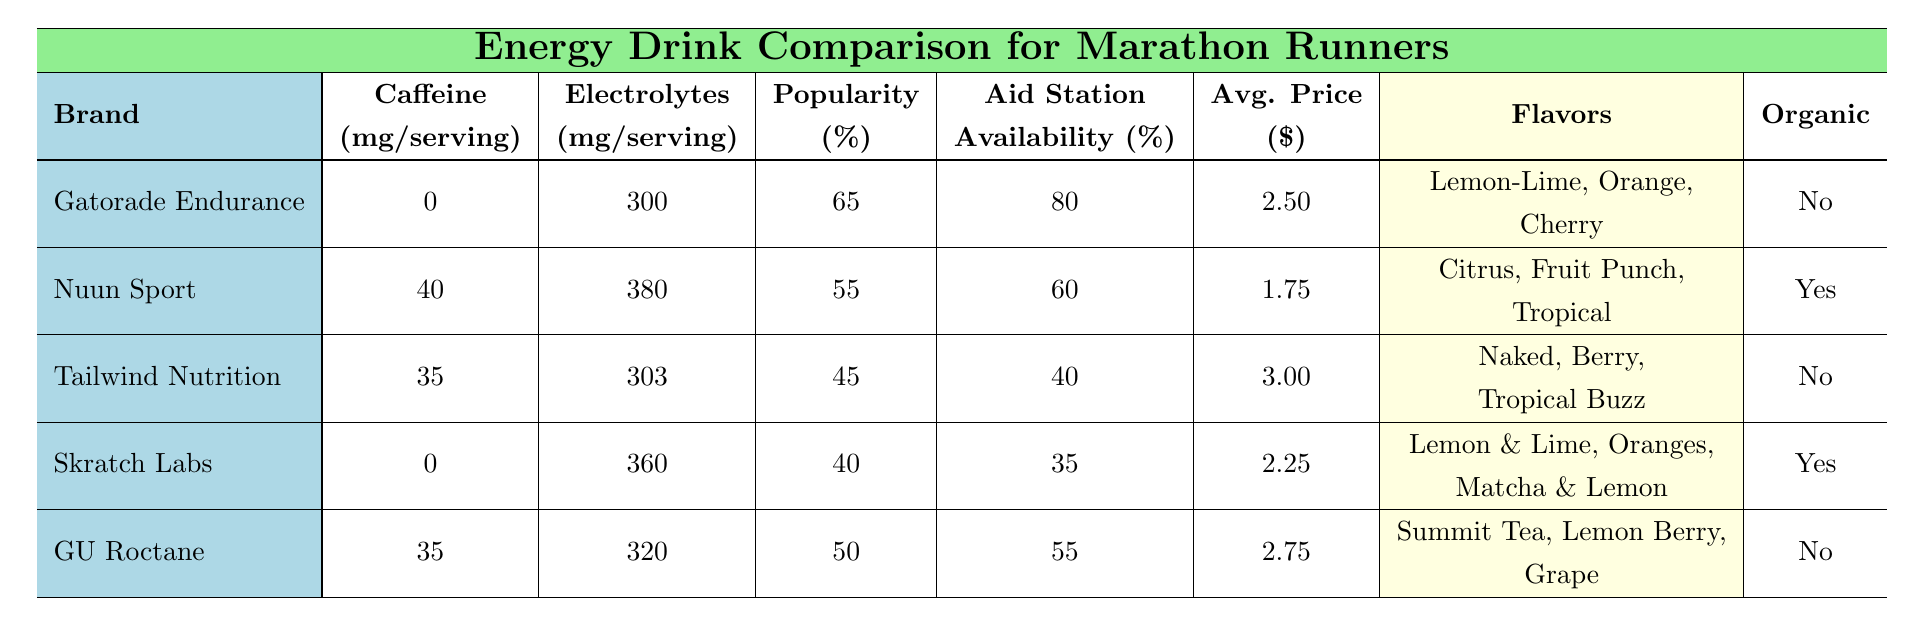What is the average caffeine content in the energy drinks listed? The caffeine contents listed are: 0, 40, 35, 0, and 35 mg. Adding these values gives 0 + 40 + 35 + 0 + 35 = 110 mg. There are 5 drinks, so the average is 110 / 5 = 22 mg.
Answer: 22 mg Which energy drink has the highest popularity among runners? The popularity percentages are: Gatorade Endurance: 65%, Nuun Sport: 55%, Tailwind Nutrition: 45%, Skratch Labs: 40%, and GU Roctane: 50%. Gatorade Endurance has the highest percentage at 65%.
Answer: Gatorade Endurance Is Nuun Sport organic? The table indicates that Nuun Sport is marked as "Yes" in the Organic column.
Answer: Yes What is the combined electrolytes content for Skratch Labs and Tailwind Nutrition? Skratch Labs has an electrolyte content of 360 mg, and Tailwind Nutrition has 303 mg. Adding these gives 360 + 303 = 663 mg for both drinks combined.
Answer: 663 mg Which drink is most frequently available at aid stations and what is that percentage? The availability percentages are Gatorade Endurance: 80%, Nuun Sport: 60%, Tailwind Nutrition: 40%, Skratch Labs: 35%, and GU Roctane: 55%. Gatorade Endurance is available at the highest percentage of 80%.
Answer: Gatorade Endurance, 80% What is the price range of the energy drinks listed? The average prices are: Gatorade Endurance: $2.50, Nuun Sport: $1.75, Tailwind Nutrition: $3.00, Skratch Labs: $2.25, GU Roctane: $2.75. The lowest price is $1.75, and the highest is $3.00.
Answer: $1.75 - $3.00 If we consider only drinks with caffeine, what is the percentage popularity of those drinks? The drinks with caffeine are Nuun Sport (55% popularity), Tailwind Nutrition (45%), and GU Roctane (50%). So, 3 drinks out of 5 have caffeine. The combined popularity is 55 + 45 + 50 = 150%. To find the percentage popularity of those drinks relative to all drinks: (150 / (65 + 55 + 45 + 40 + 50)) * 100 = (150 / 255) * 100 ≈ 58.82%.
Answer: Approximately 58.82% What is the most popular drink flavor for Gatorade Endurance? The flavors listed for Gatorade Endurance are Lemon-Lime, Orange, and Cherry. Since no specific popularity is assigned to flavors, we cannot determine which flavor is most popular based on the provided data. However, any of the flavors could be equally favored among runners.
Answer: Not determinable 